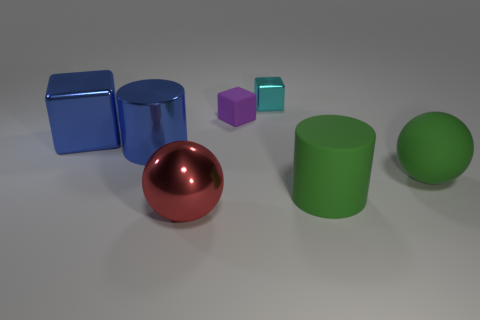There is a thing that is the same color as the large metallic cube; what is its shape?
Your response must be concise. Cylinder. There is a big thing that is both to the right of the tiny metal object and left of the rubber sphere; what is its material?
Give a very brief answer. Rubber. Do the shiny cylinder and the big matte ball have the same color?
Make the answer very short. No. There is a block that is the same size as the cyan metallic thing; what is its color?
Your answer should be compact. Purple. What number of things are either red things or shiny things?
Provide a short and direct response. 4. What is the size of the block that is on the right side of the large metal sphere and in front of the tiny cyan block?
Make the answer very short. Small. How many large green cylinders have the same material as the tiny cyan block?
Your answer should be compact. 0. There is a small thing that is made of the same material as the big red object; what color is it?
Make the answer very short. Cyan. Is the color of the cylinder that is in front of the blue cylinder the same as the tiny metallic thing?
Your response must be concise. No. What is the big cylinder to the left of the big red thing made of?
Offer a very short reply. Metal. 